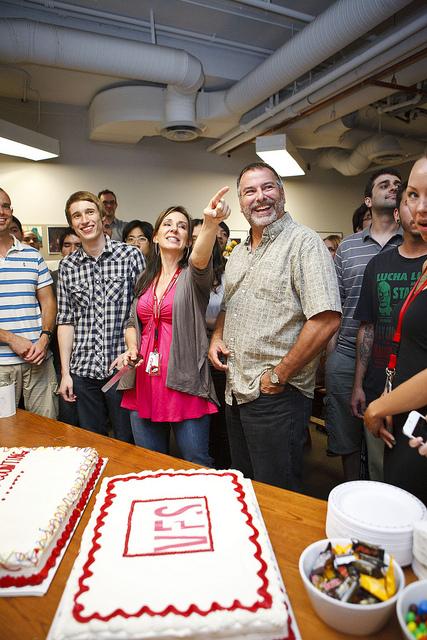What are these people lining up to eat?
Concise answer only. Cake. What is the cake for?
Quick response, please. Celebration. What is she wearing?
Keep it brief. Pink shirt. What are the initials on the cake?
Answer briefly. Vfs. What is in the styrofoam bowls?
Quick response, please. Candy. Is there pizza in the image?
Write a very short answer. No. 